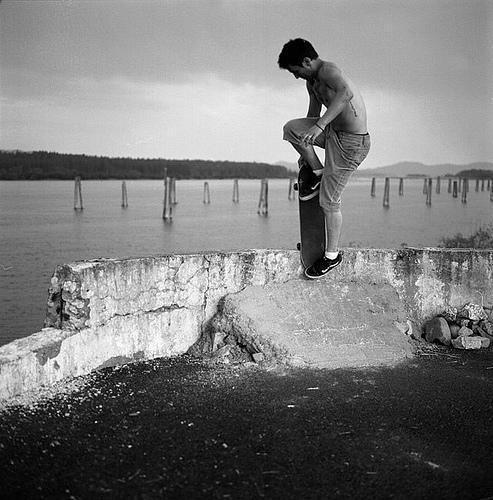How many people can be seen?
Give a very brief answer. 1. 